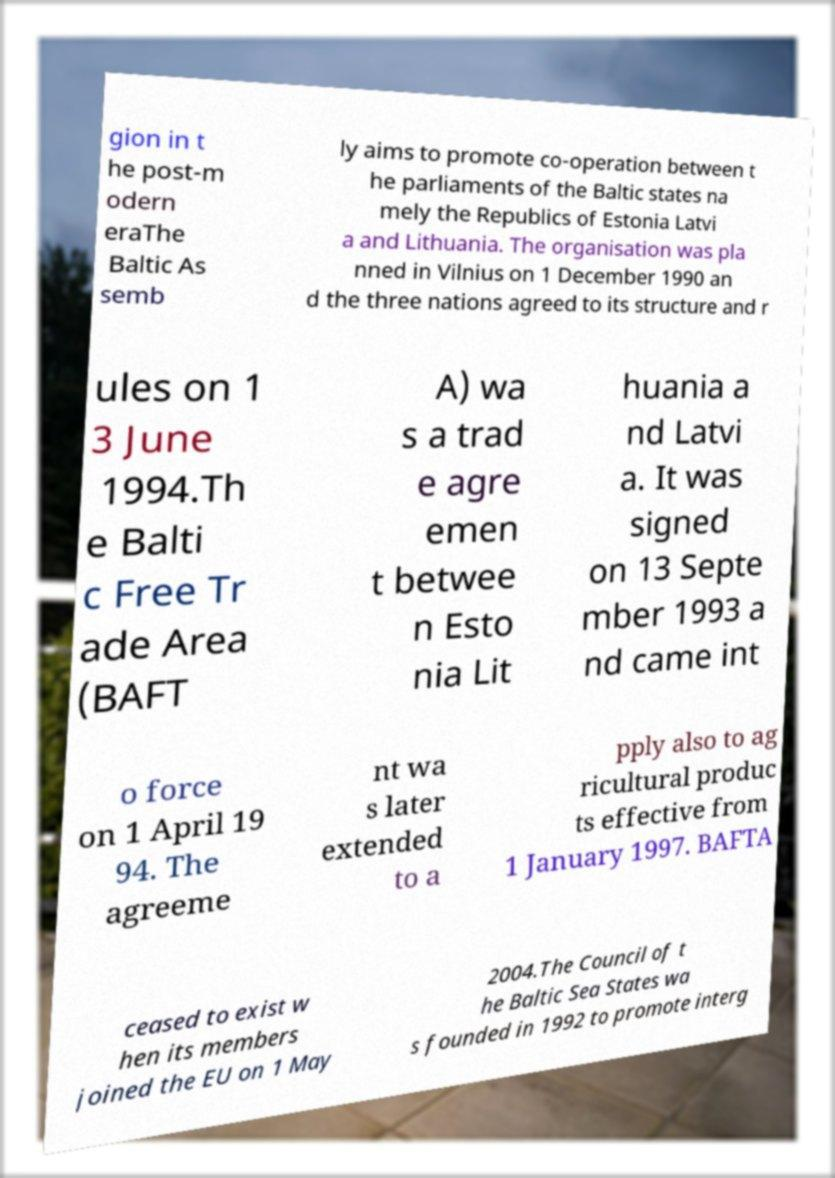What messages or text are displayed in this image? I need them in a readable, typed format. gion in t he post-m odern eraThe Baltic As semb ly aims to promote co-operation between t he parliaments of the Baltic states na mely the Republics of Estonia Latvi a and Lithuania. The organisation was pla nned in Vilnius on 1 December 1990 an d the three nations agreed to its structure and r ules on 1 3 June 1994.Th e Balti c Free Tr ade Area (BAFT A) wa s a trad e agre emen t betwee n Esto nia Lit huania a nd Latvi a. It was signed on 13 Septe mber 1993 a nd came int o force on 1 April 19 94. The agreeme nt wa s later extended to a pply also to ag ricultural produc ts effective from 1 January 1997. BAFTA ceased to exist w hen its members joined the EU on 1 May 2004.The Council of t he Baltic Sea States wa s founded in 1992 to promote interg 